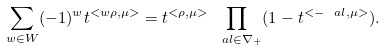<formula> <loc_0><loc_0><loc_500><loc_500>\sum _ { w \in W } ( - 1 ) ^ { w } t ^ { < w \rho , \mu > } = t ^ { < \rho , \mu > } \prod _ { \ a l \in \nabla _ { + } } ( 1 - t ^ { < - \ a l , \mu > } ) .</formula> 